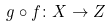Convert formula to latex. <formula><loc_0><loc_0><loc_500><loc_500>g \circ f \colon X \rightarrow Z</formula> 